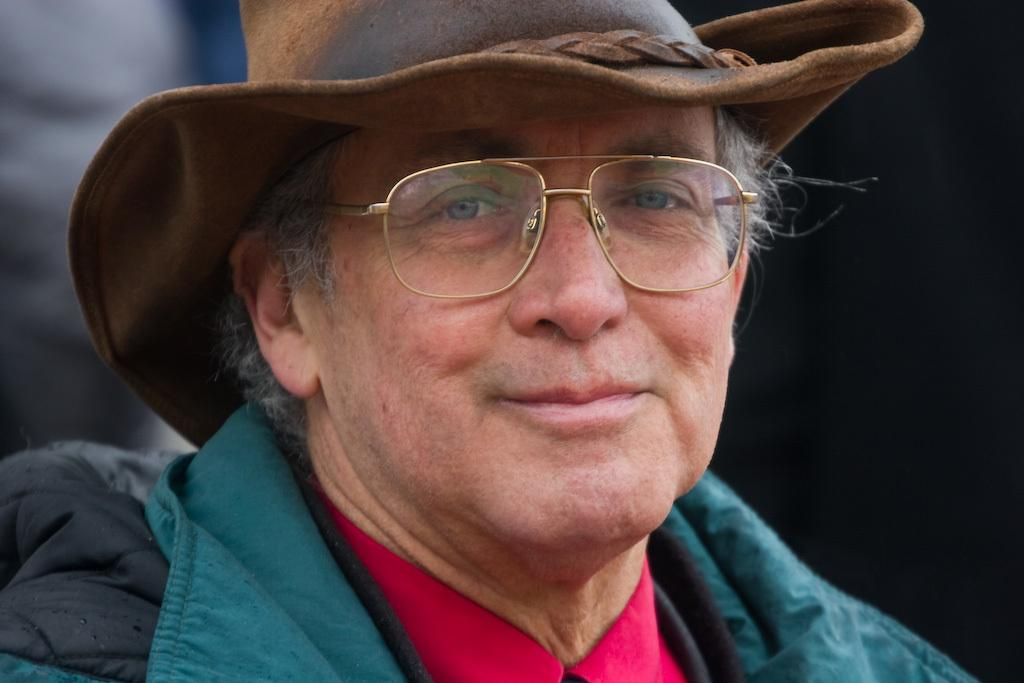Who is the main subject in the image? The main subject in the image is an old man. What is the old man wearing on his head? The old man is wearing a hat. What accessory is the old man wearing on his face? The old man is wearing spectacles. Who is the old man looking at? The old man is looking at someone, but we cannot see the person in the image. What expression does the old man have on his face? The old man is smiling. What type of pies is the old man selling in the image? There is no indication in the image that the old man is selling pies, nor are any pies visible. 